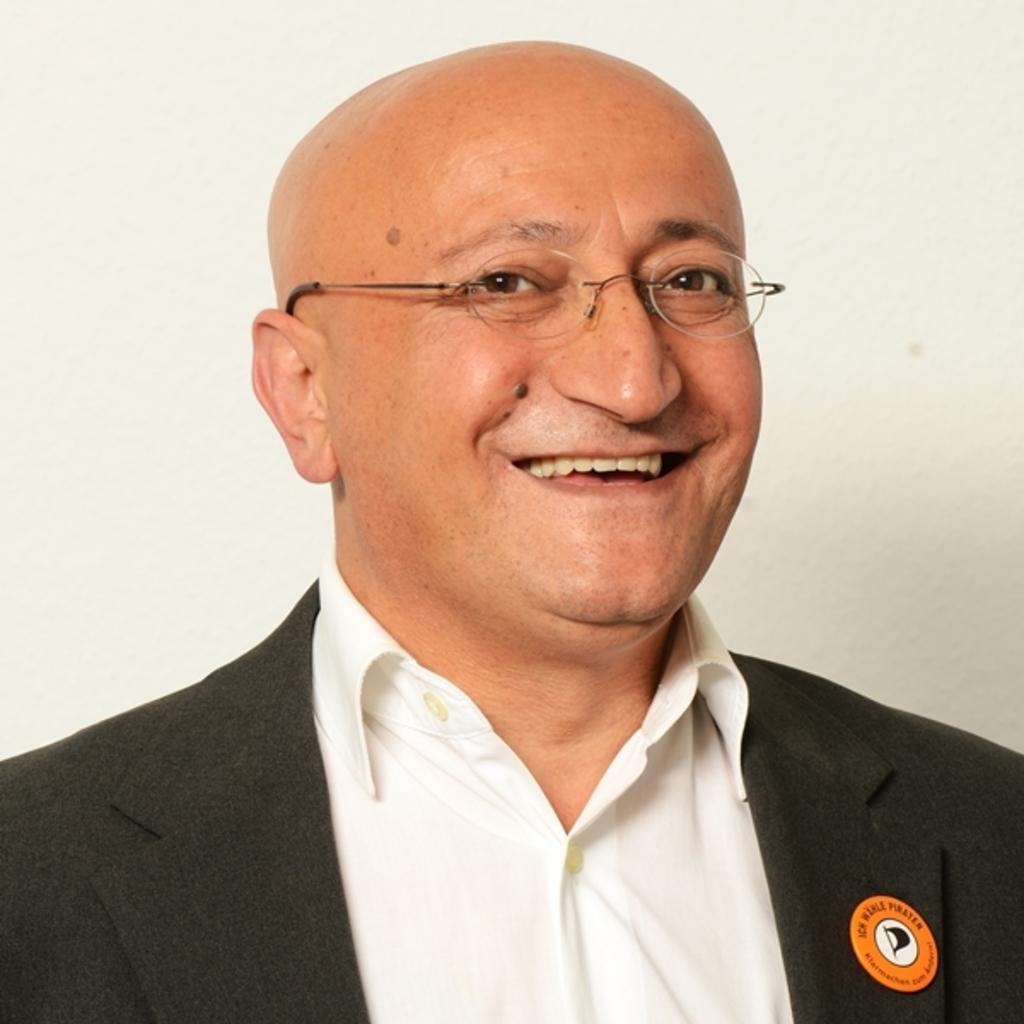What is the appearance of the man in the image? The man in the image is wearing a black suit and spectacles. What is the man's facial expression in the image? The man is smiling in the image. Can you describe the background of the image? There is a well in the background of the image. What type of quartz can be seen in the man's hand in the image? There is no quartz present in the image. 